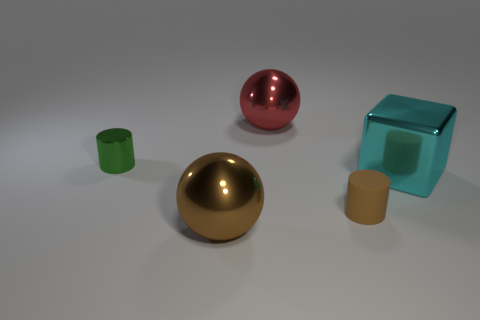Are there any other things that have the same size as the brown shiny thing?
Your answer should be very brief. Yes. There is a object behind the tiny cylinder that is behind the matte thing; what is it made of?
Your answer should be compact. Metal. Is the large brown object the same shape as the big cyan metal object?
Provide a succinct answer. No. How many cylinders are both behind the small rubber cylinder and to the right of the green metal cylinder?
Make the answer very short. 0. Are there an equal number of small green metal things right of the small shiny cylinder and large objects that are right of the tiny brown object?
Your response must be concise. No. Is the size of the cylinder on the left side of the red shiny ball the same as the cylinder in front of the cyan object?
Your answer should be compact. Yes. There is a large thing that is in front of the small green cylinder and to the right of the brown metallic thing; what material is it made of?
Offer a very short reply. Metal. Is the number of red objects less than the number of large green objects?
Give a very brief answer. No. There is a sphere behind the tiny green thing behind the rubber cylinder; how big is it?
Provide a short and direct response. Large. There is a small object that is in front of the small thing to the left of the sphere in front of the small brown cylinder; what shape is it?
Offer a very short reply. Cylinder. 